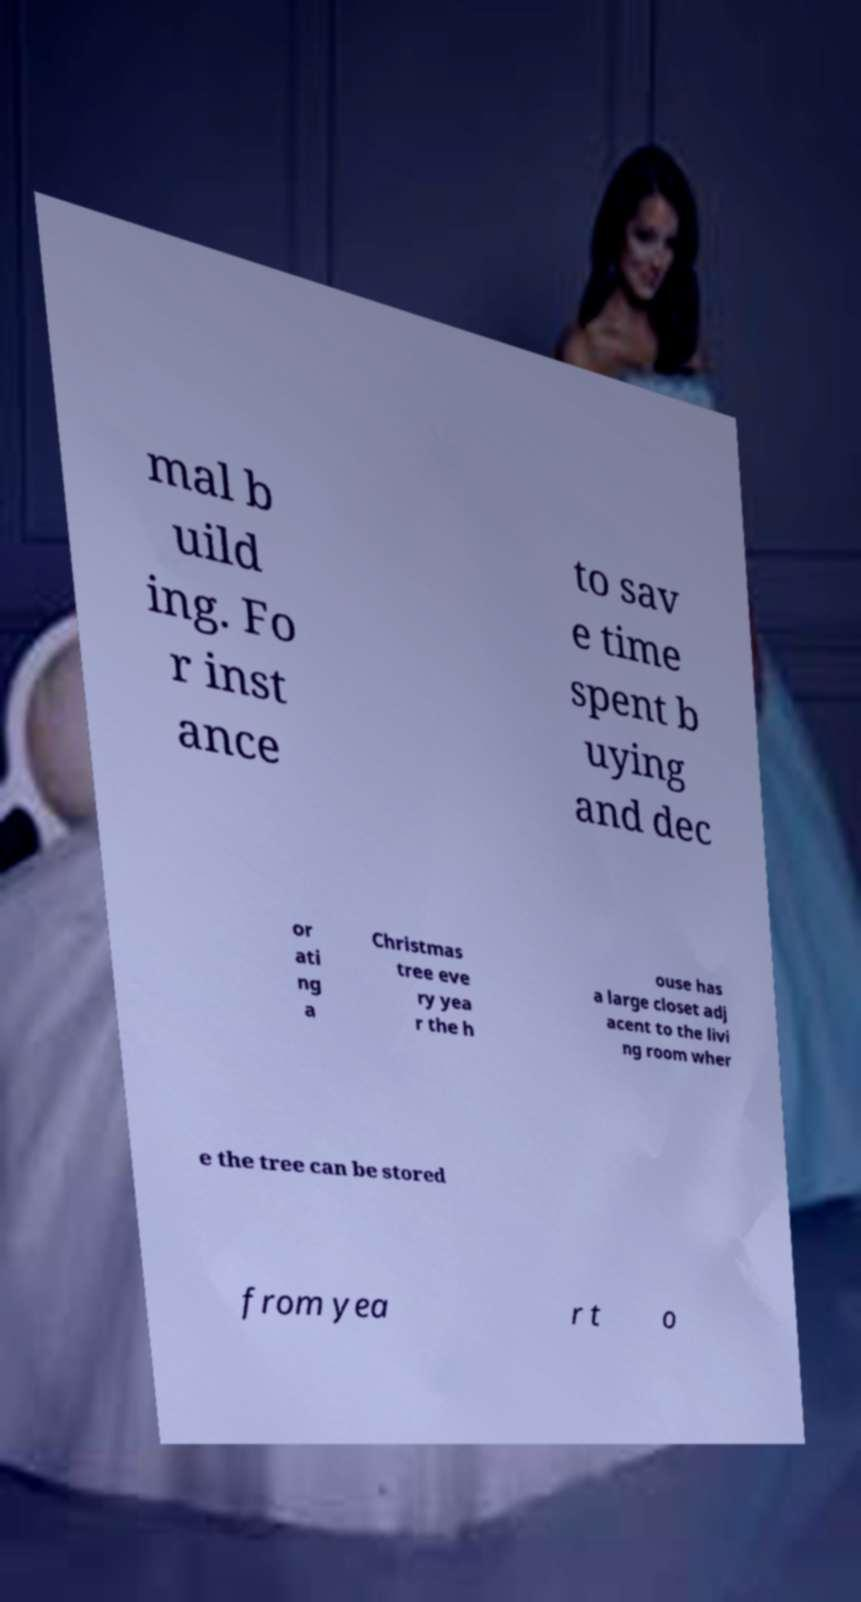Can you read and provide the text displayed in the image?This photo seems to have some interesting text. Can you extract and type it out for me? mal b uild ing. Fo r inst ance to sav e time spent b uying and dec or ati ng a Christmas tree eve ry yea r the h ouse has a large closet adj acent to the livi ng room wher e the tree can be stored from yea r t o 